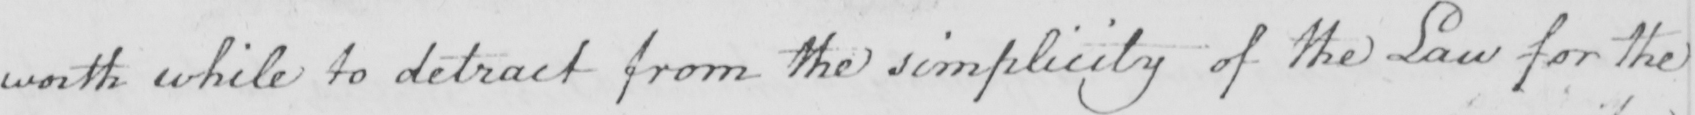Please transcribe the handwritten text in this image. worth while to detract from the simplicity of the Law for the 